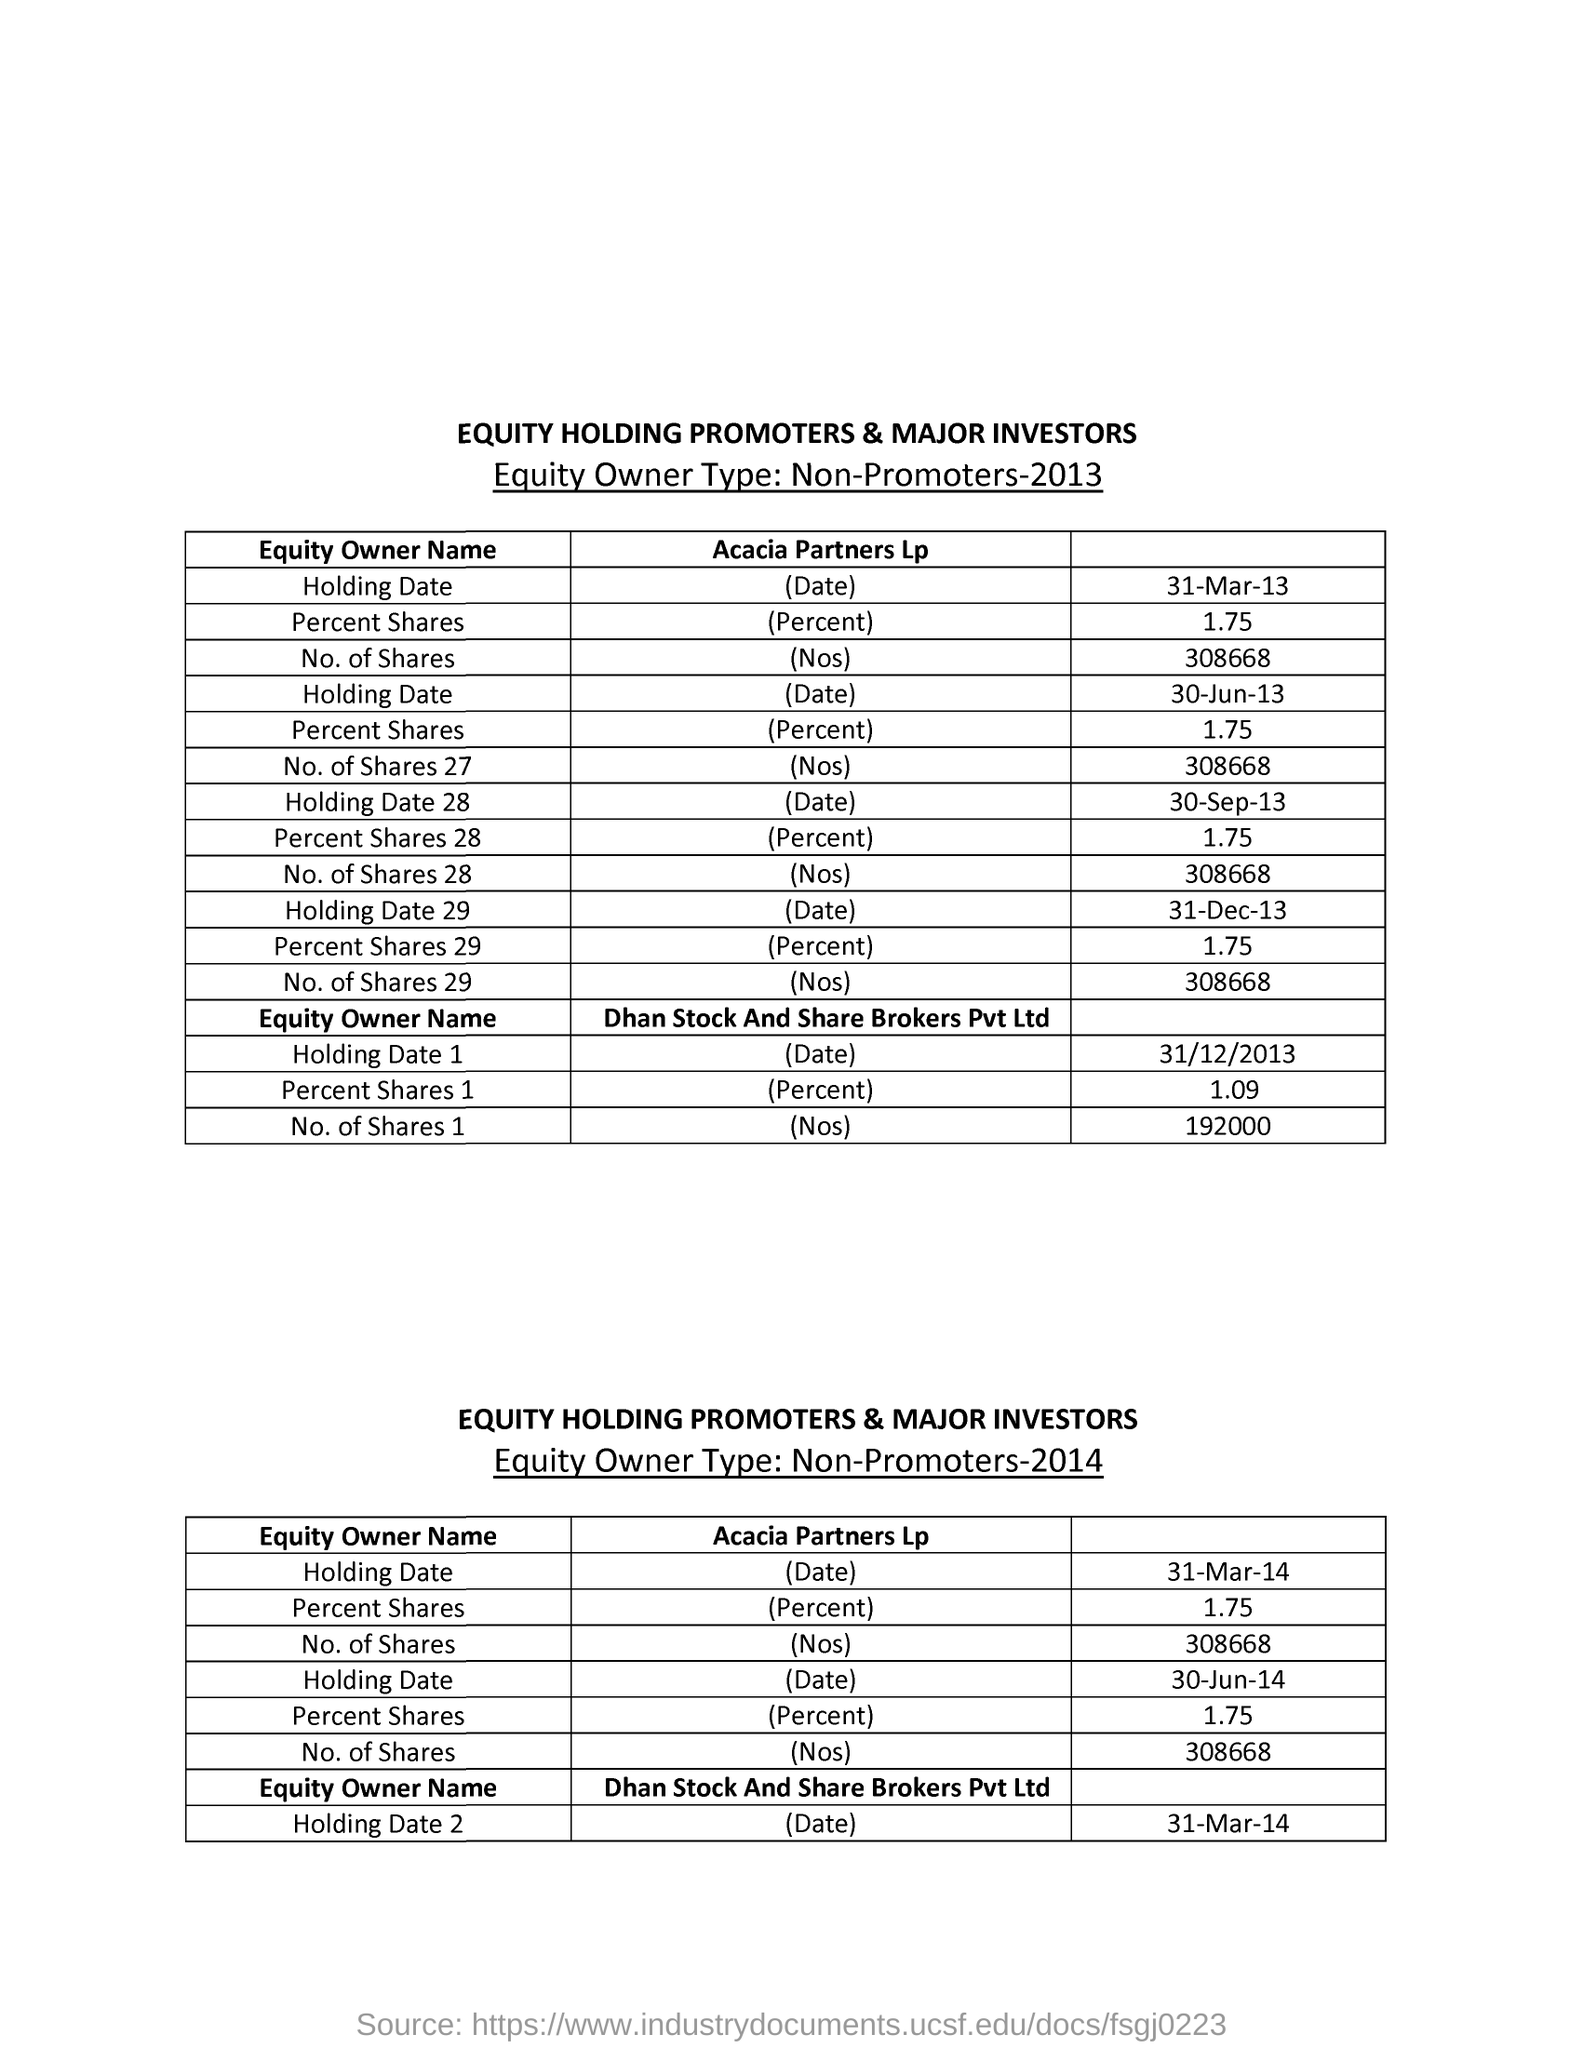Highlight a few significant elements in this photo. On 31-Mar-13, the percent share of Acacia Partners Lp was 1.75%. On December 31, 2013, Dhan Stock and Share Brokers Pvt Ltd had 192,000 shares. 